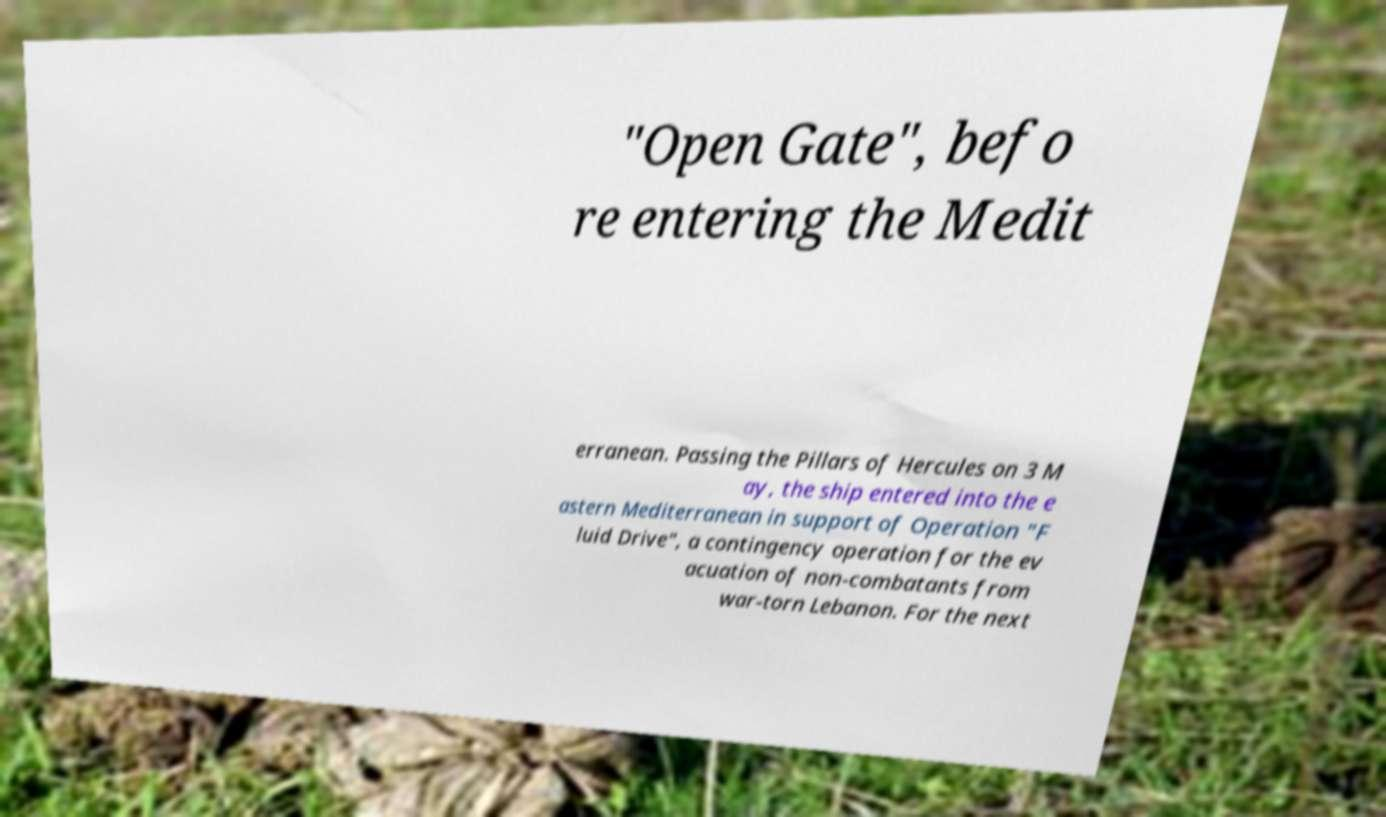Could you extract and type out the text from this image? "Open Gate", befo re entering the Medit erranean. Passing the Pillars of Hercules on 3 M ay, the ship entered into the e astern Mediterranean in support of Operation "F luid Drive", a contingency operation for the ev acuation of non-combatants from war-torn Lebanon. For the next 